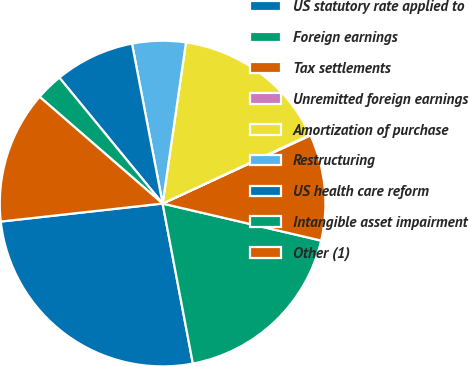<chart> <loc_0><loc_0><loc_500><loc_500><pie_chart><fcel>US statutory rate applied to<fcel>Foreign earnings<fcel>Tax settlements<fcel>Unremitted foreign earnings<fcel>Amortization of purchase<fcel>Restructuring<fcel>US health care reform<fcel>Intangible asset impairment<fcel>Other (1)<nl><fcel>26.21%<fcel>18.37%<fcel>10.53%<fcel>0.07%<fcel>15.76%<fcel>5.3%<fcel>7.92%<fcel>2.69%<fcel>13.14%<nl></chart> 